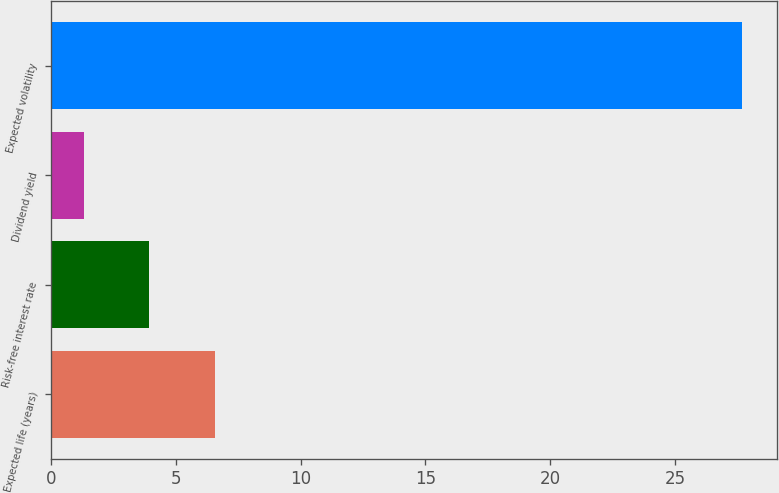Convert chart to OTSL. <chart><loc_0><loc_0><loc_500><loc_500><bar_chart><fcel>Expected life (years)<fcel>Risk-free interest rate<fcel>Dividend yield<fcel>Expected volatility<nl><fcel>6.58<fcel>3.94<fcel>1.3<fcel>27.7<nl></chart> 